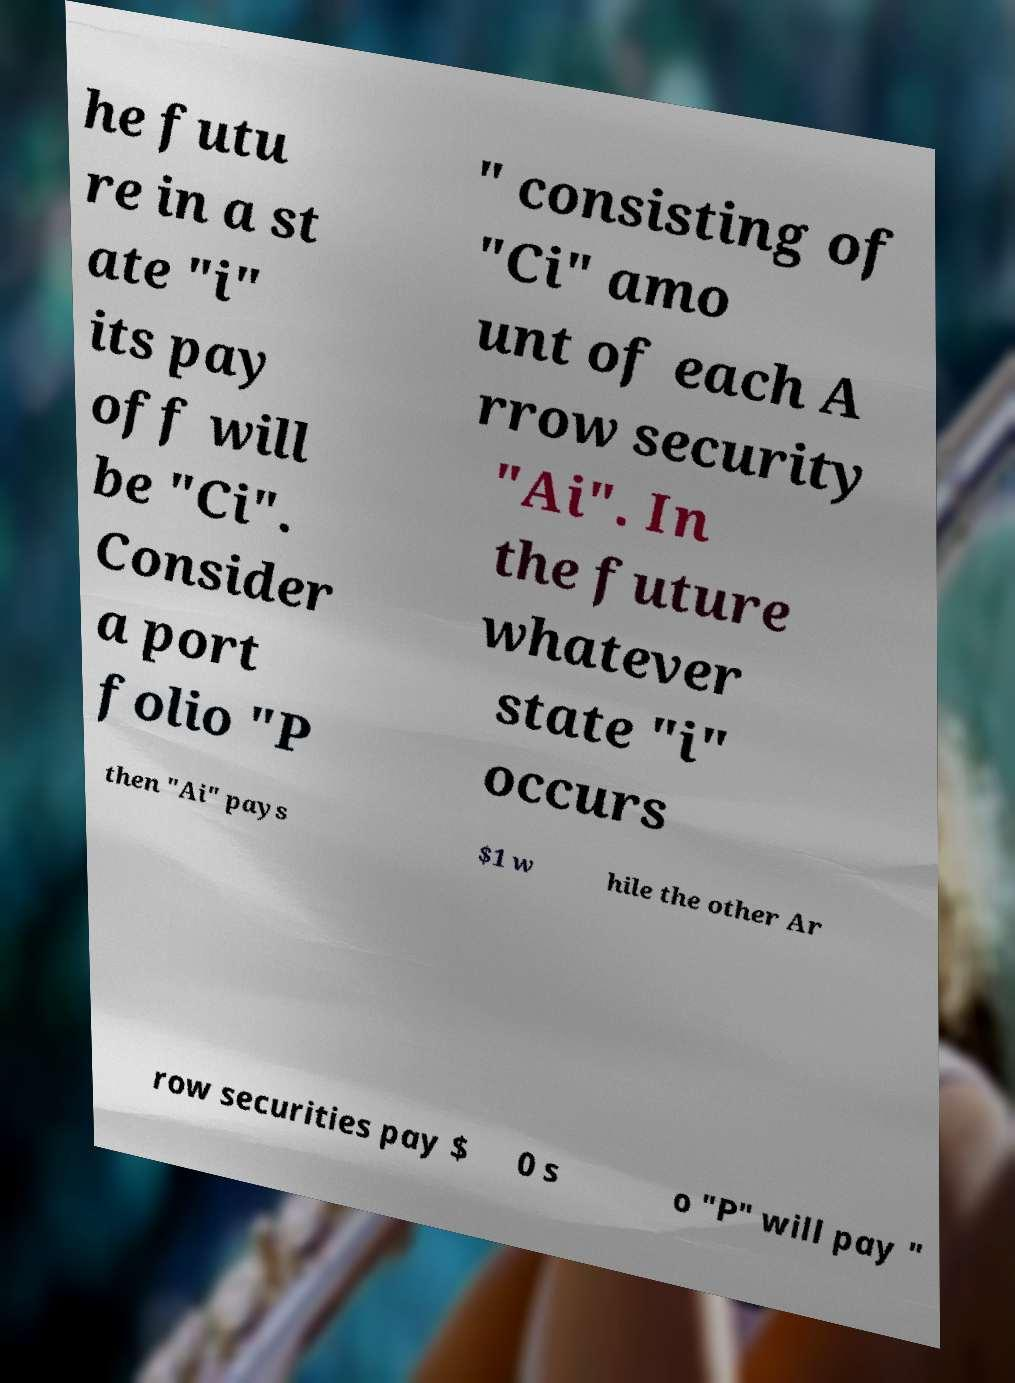What messages or text are displayed in this image? I need them in a readable, typed format. he futu re in a st ate "i" its pay off will be "Ci". Consider a port folio "P " consisting of "Ci" amo unt of each A rrow security "Ai". In the future whatever state "i" occurs then "Ai" pays $1 w hile the other Ar row securities pay $ 0 s o "P" will pay " 